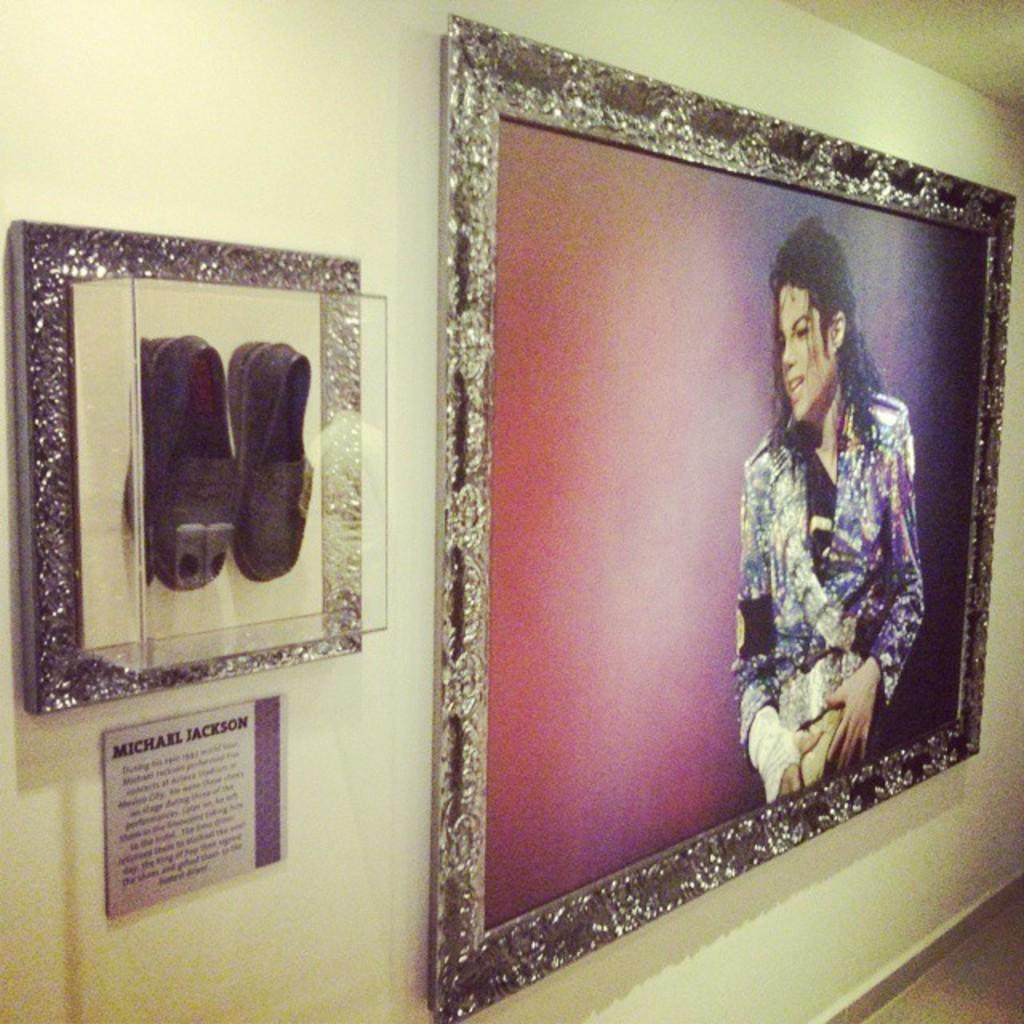What object can be seen on the wall in the image? There is a photo frame on the wall in the image. What unusual item can be seen in a glass box in the image? There are shoes in a glass box in the image. Can you see any snails crawling on the photo frame in the image? There are no snails visible on the photo frame in the image. How many toes can be seen on the shoes in the glass box? The image does not show the toes of the person who might wear the shoes; it only shows the shoes in a glass box. 